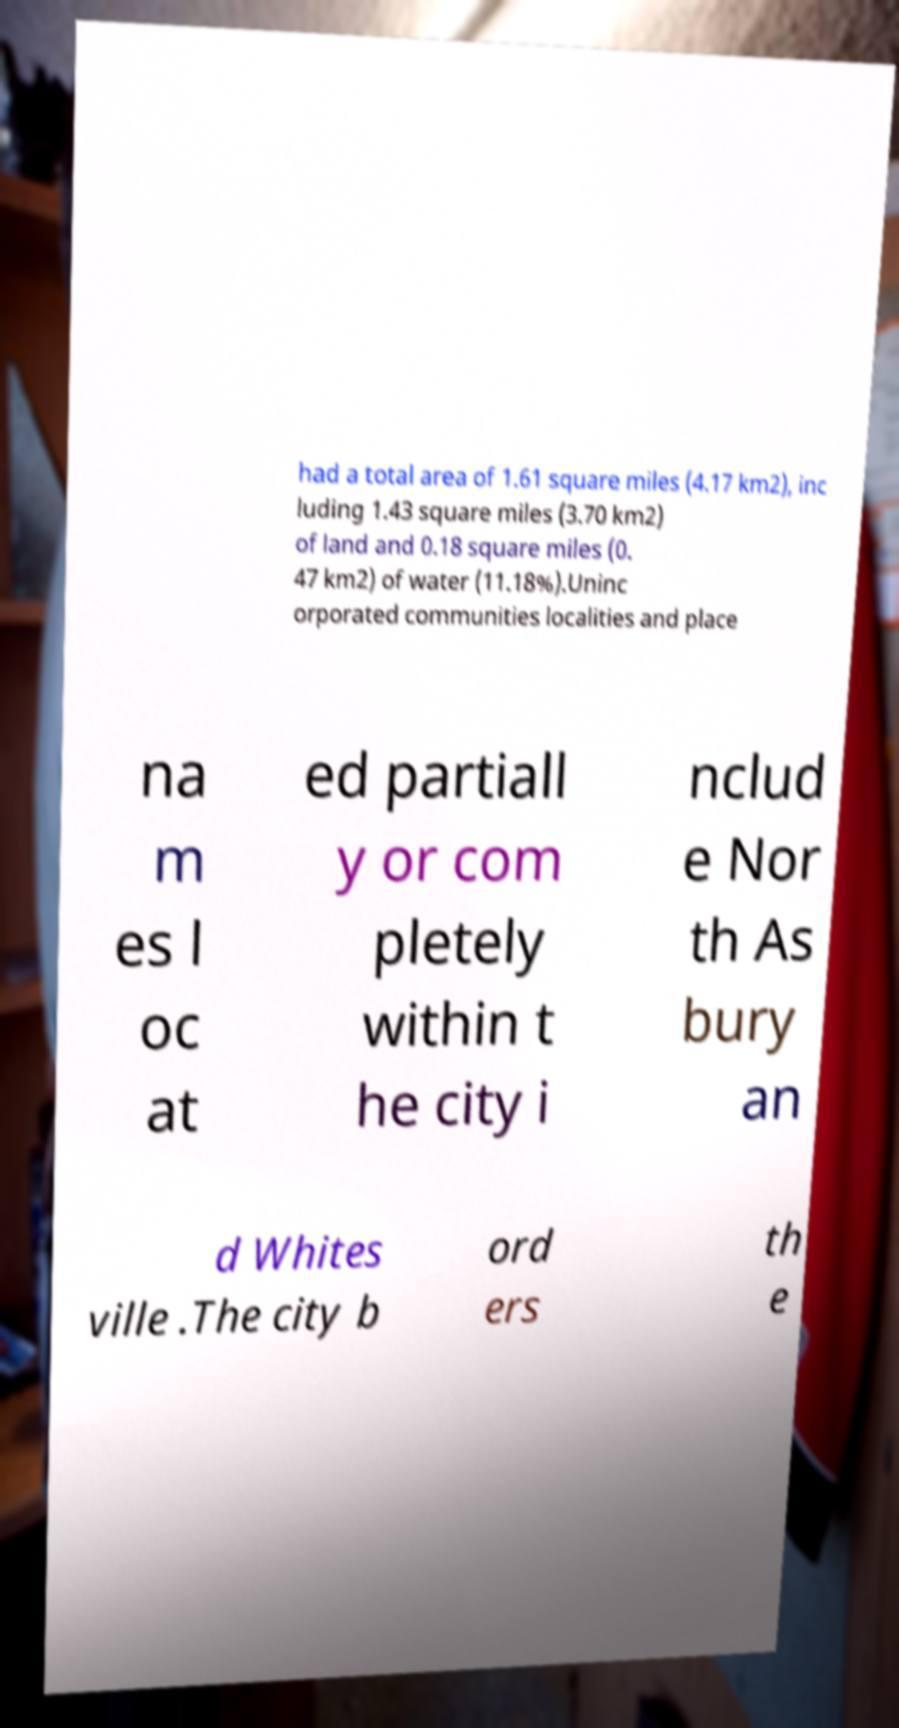Can you accurately transcribe the text from the provided image for me? had a total area of 1.61 square miles (4.17 km2), inc luding 1.43 square miles (3.70 km2) of land and 0.18 square miles (0. 47 km2) of water (11.18%).Uninc orporated communities localities and place na m es l oc at ed partiall y or com pletely within t he city i nclud e Nor th As bury an d Whites ville .The city b ord ers th e 